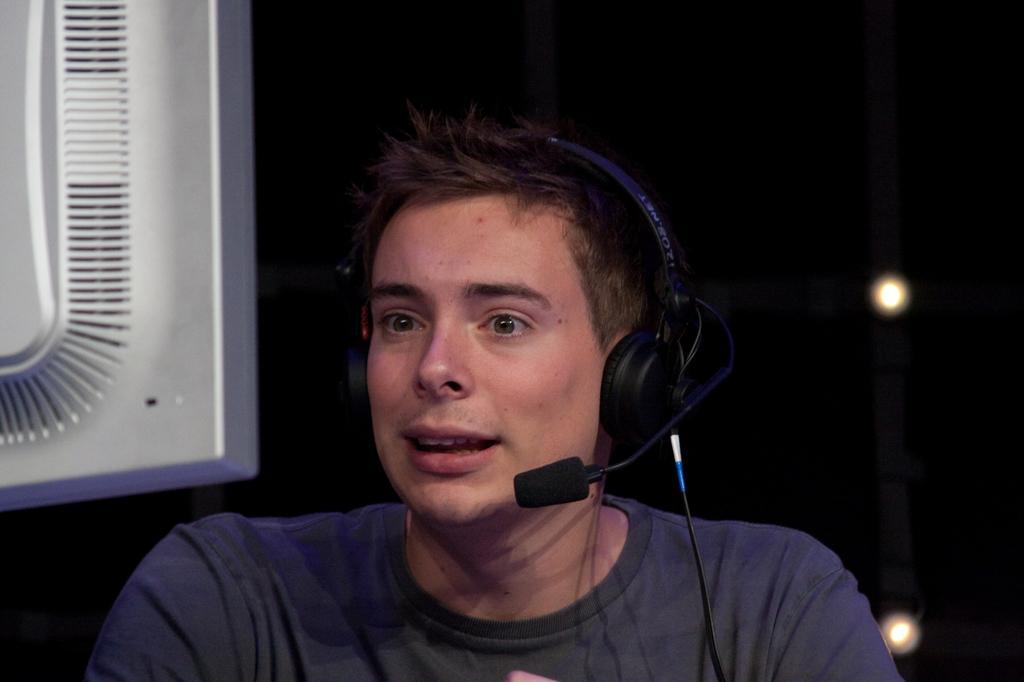Can you describe this image briefly? In this picture we can see a man, he wore a headset, in front of him we can find a monitor, in the background we can see few lights. 